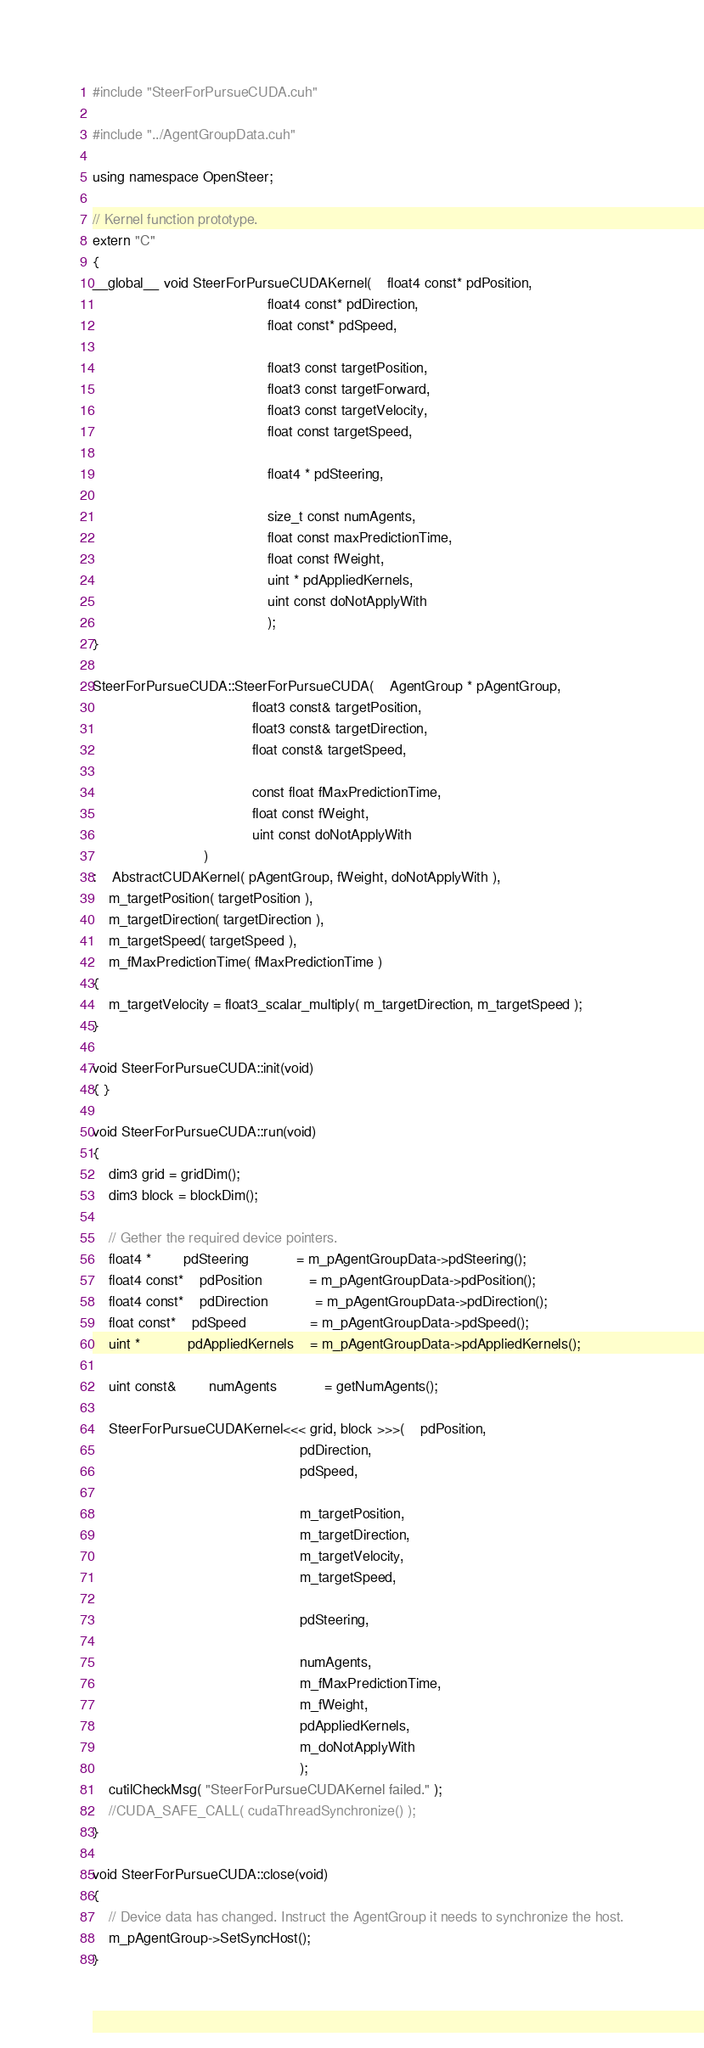<code> <loc_0><loc_0><loc_500><loc_500><_Cuda_>#include "SteerForPursueCUDA.cuh"

#include "../AgentGroupData.cuh"

using namespace OpenSteer;

// Kernel function prototype.
extern "C"
{
__global__ void SteerForPursueCUDAKernel(	float4 const* pdPosition,
											float4 const* pdDirection,
											float const* pdSpeed, 

											float3 const targetPosition,
											float3 const targetForward,
											float3 const targetVelocity,
											float const targetSpeed,

											float4 * pdSteering,

											size_t const numAgents,
											float const maxPredictionTime,
											float const fWeight,
											uint * pdAppliedKernels,
											uint const doNotApplyWith
											);
}

SteerForPursueCUDA::SteerForPursueCUDA(	AgentGroup * pAgentGroup, 
										float3 const& targetPosition,
										float3 const& targetDirection,
										float const& targetSpeed,

										const float fMaxPredictionTime,
										float const fWeight,
										uint const doNotApplyWith
							)
:	AbstractCUDAKernel( pAgentGroup, fWeight, doNotApplyWith ),
	m_targetPosition( targetPosition ),
	m_targetDirection( targetDirection ),
	m_targetSpeed( targetSpeed ),
	m_fMaxPredictionTime( fMaxPredictionTime )
{
	m_targetVelocity = float3_scalar_multiply( m_targetDirection, m_targetSpeed );
}

void SteerForPursueCUDA::init(void)
{ }

void SteerForPursueCUDA::run(void)
{
	dim3 grid = gridDim();
	dim3 block = blockDim();

	// Gether the required device pointers.
	float4 *		pdSteering			= m_pAgentGroupData->pdSteering();
	float4 const*	pdPosition			= m_pAgentGroupData->pdPosition();
	float4 const*	pdDirection			= m_pAgentGroupData->pdDirection();
	float const*	pdSpeed				= m_pAgentGroupData->pdSpeed();
	uint *			pdAppliedKernels	= m_pAgentGroupData->pdAppliedKernels();

	uint const&		numAgents			= getNumAgents();

	SteerForPursueCUDAKernel<<< grid, block >>>(	pdPosition,
													pdDirection,
													pdSpeed,

													m_targetPosition,
													m_targetDirection,
													m_targetVelocity,
													m_targetSpeed,

													pdSteering,

													numAgents,
													m_fMaxPredictionTime,
													m_fWeight,
													pdAppliedKernels,
													m_doNotApplyWith
													);
	cutilCheckMsg( "SteerForPursueCUDAKernel failed." );
	//CUDA_SAFE_CALL( cudaThreadSynchronize() );
}

void SteerForPursueCUDA::close(void)
{
	// Device data has changed. Instruct the AgentGroup it needs to synchronize the host.
	m_pAgentGroup->SetSyncHost();
}
</code> 